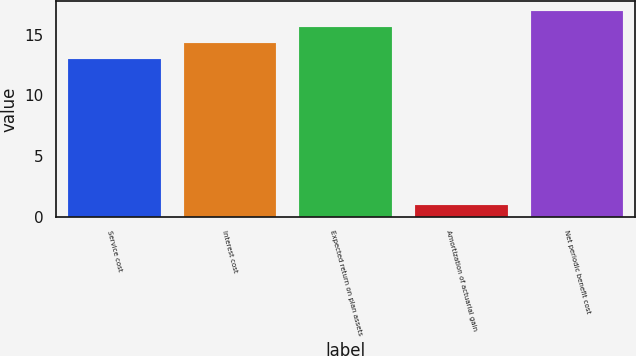Convert chart. <chart><loc_0><loc_0><loc_500><loc_500><bar_chart><fcel>Service cost<fcel>Interest cost<fcel>Expected return on plan assets<fcel>Amortization of actuarial gain<fcel>Net periodic benefit cost<nl><fcel>13<fcel>14.3<fcel>15.6<fcel>1<fcel>16.9<nl></chart> 